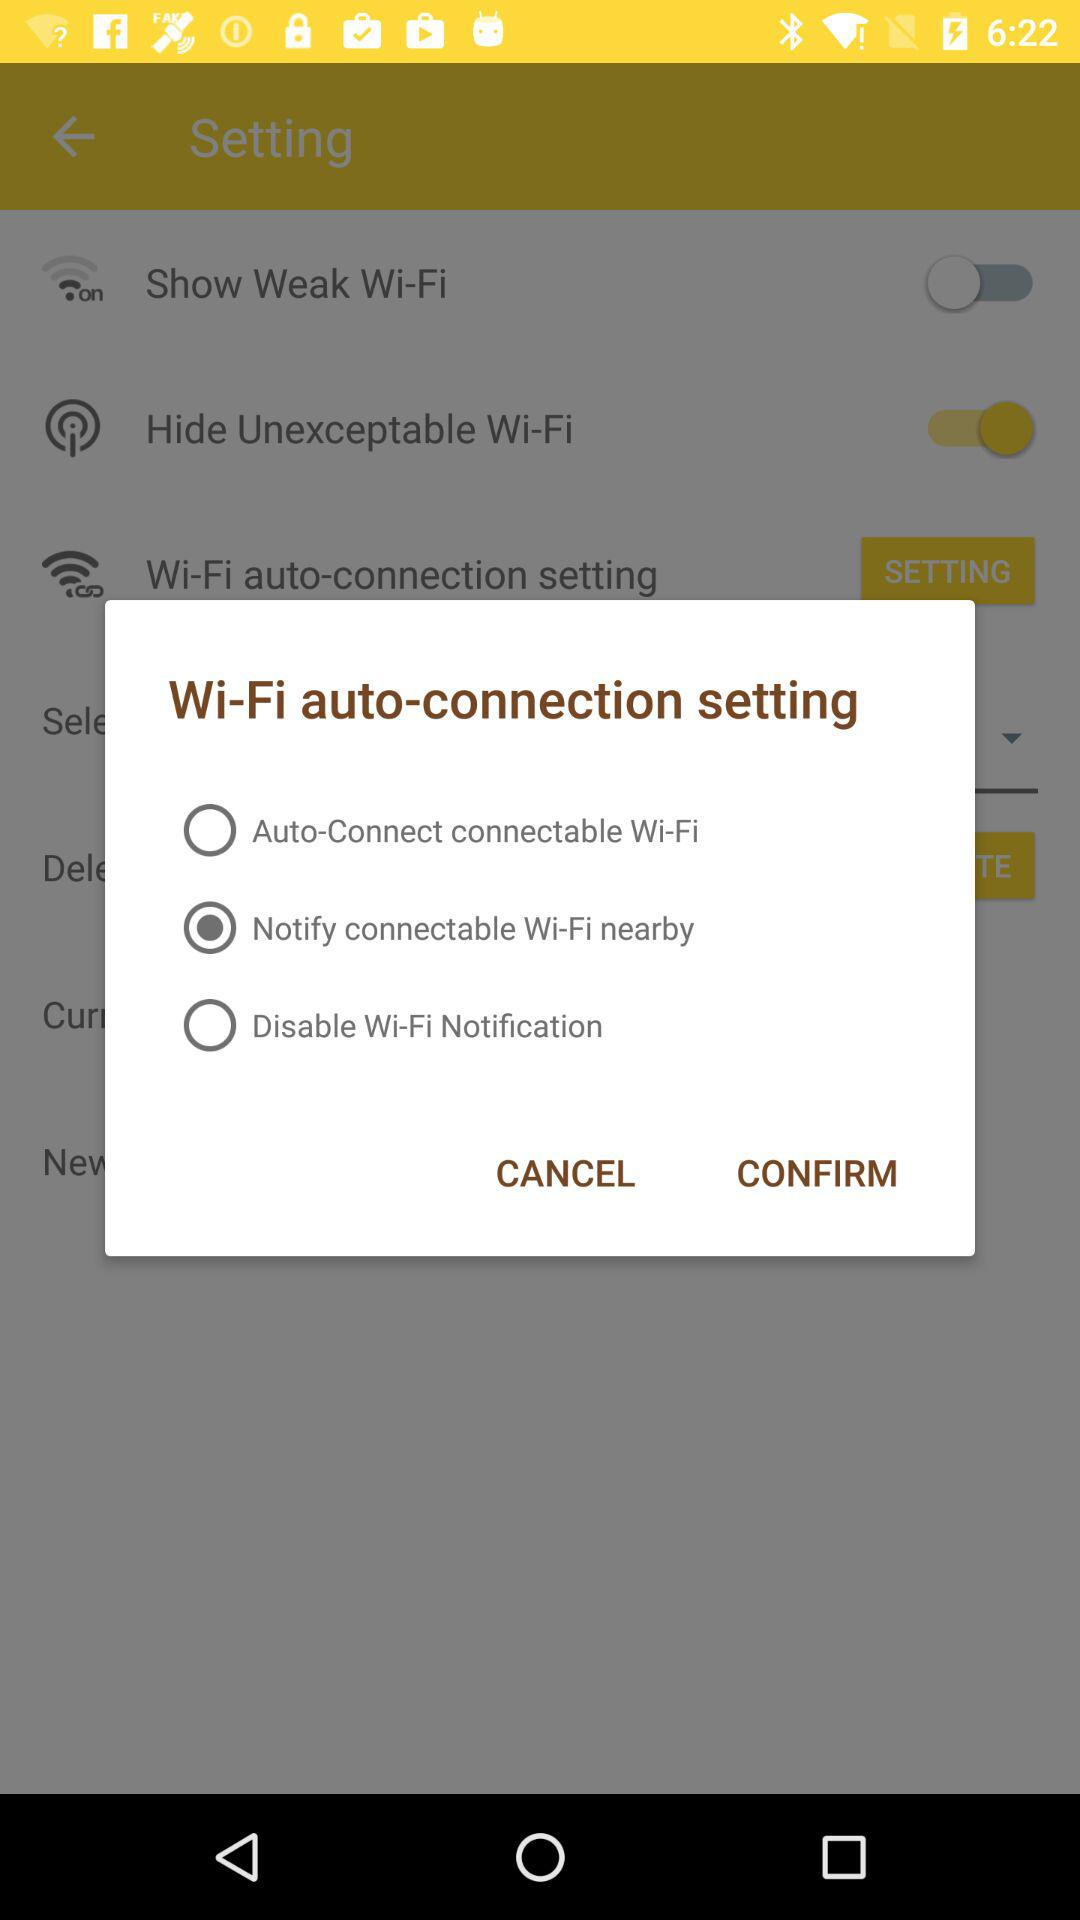Which is the selected setting? The selected setting is "Notify connectable Wi-Fi nearby". 